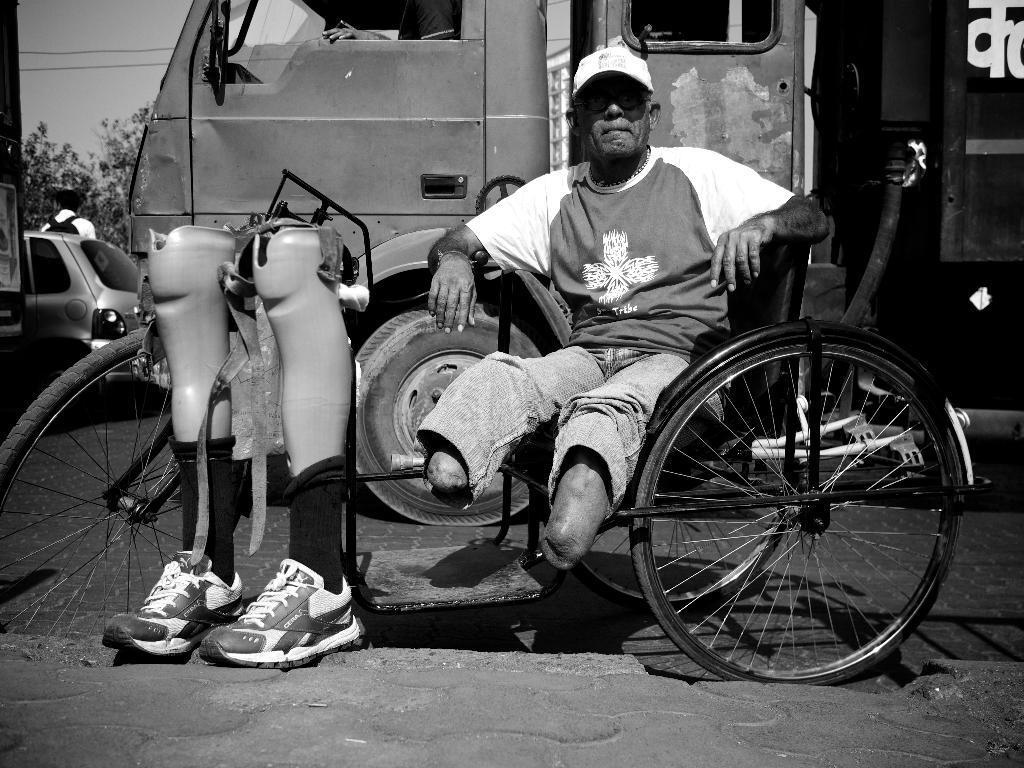Describe this image in one or two sentences. In this image a handicap person is sitting on a wheel chair. There are two artificial legs in front of him. In the background there is a truck and few other vehicles, there are trees. 